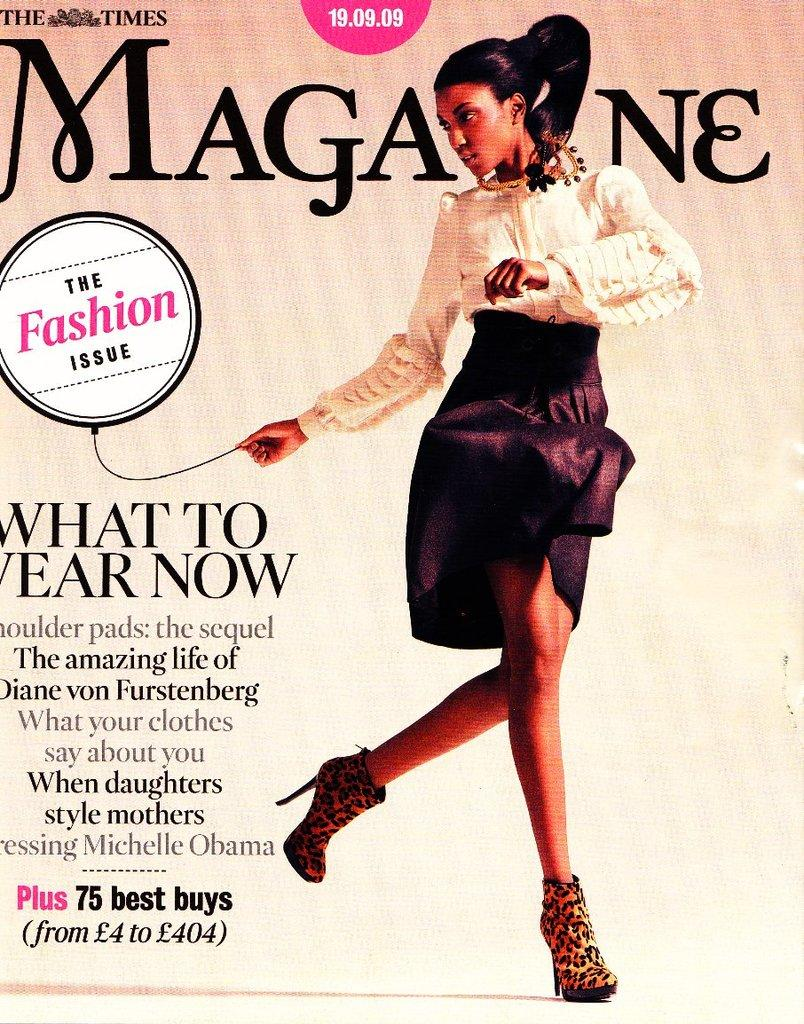What type of image is depicted on the book cover? The image is a book cover with a picture on it. What else can be seen on the book cover besides the picture? There is text on the book cover. How many boats are docked at the harbor on the book cover? There is no harbor or boats present on the book cover; it only features a picture and text. 